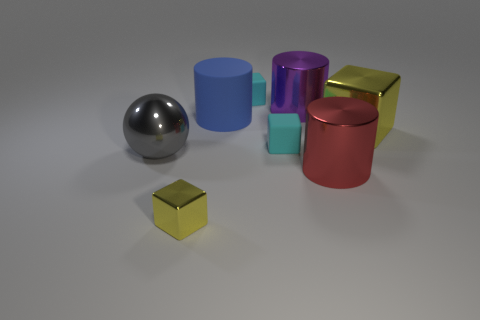Subtract all metallic cylinders. How many cylinders are left? 1 Add 2 small cylinders. How many objects exist? 10 Subtract all yellow blocks. How many blocks are left? 2 Subtract all balls. How many objects are left? 7 Subtract 1 cubes. How many cubes are left? 3 Subtract all yellow spheres. Subtract all red cylinders. How many spheres are left? 1 Subtract all blue matte objects. Subtract all blue cylinders. How many objects are left? 6 Add 5 gray shiny objects. How many gray shiny objects are left? 6 Add 1 small matte blocks. How many small matte blocks exist? 3 Subtract 0 brown cubes. How many objects are left? 8 